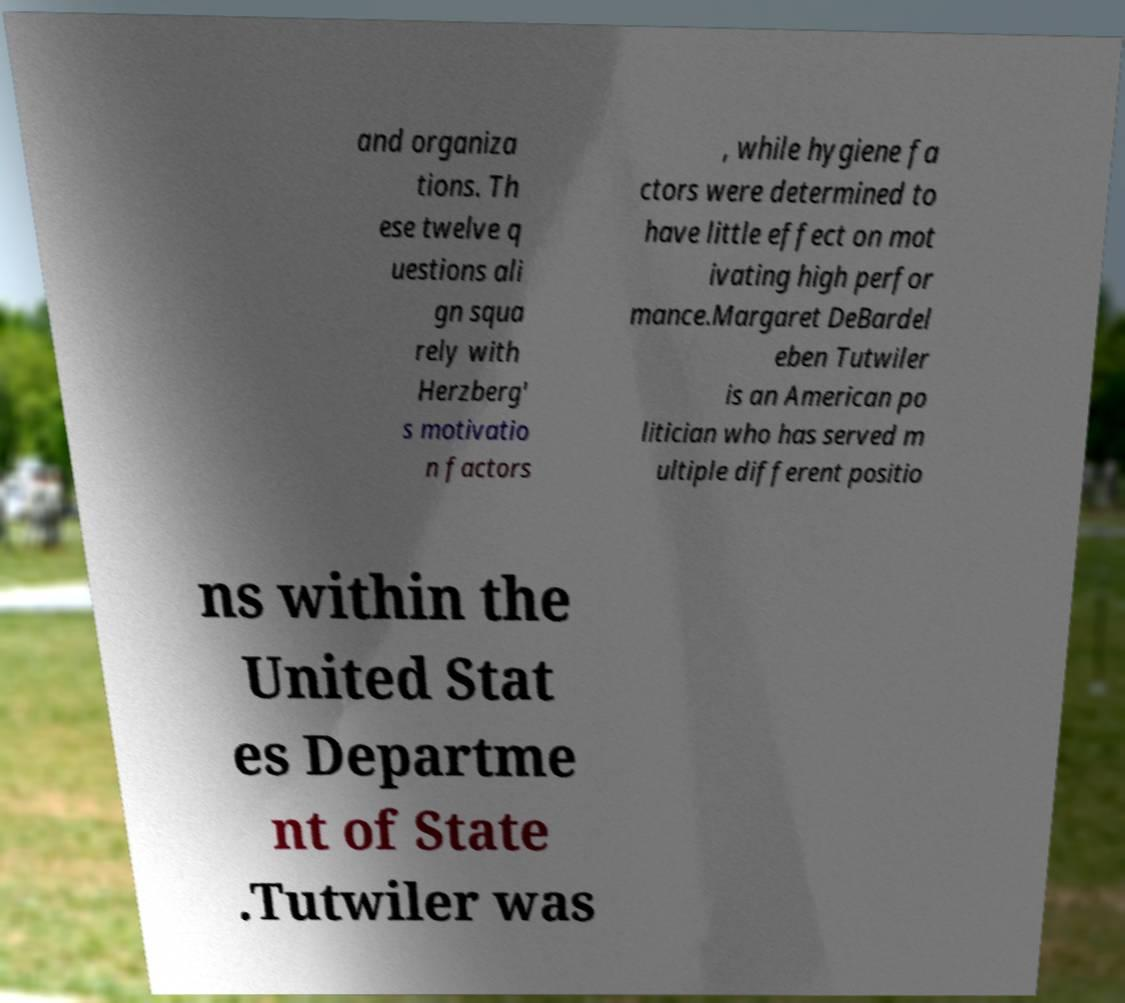Can you accurately transcribe the text from the provided image for me? and organiza tions. Th ese twelve q uestions ali gn squa rely with Herzberg' s motivatio n factors , while hygiene fa ctors were determined to have little effect on mot ivating high perfor mance.Margaret DeBardel eben Tutwiler is an American po litician who has served m ultiple different positio ns within the United Stat es Departme nt of State .Tutwiler was 